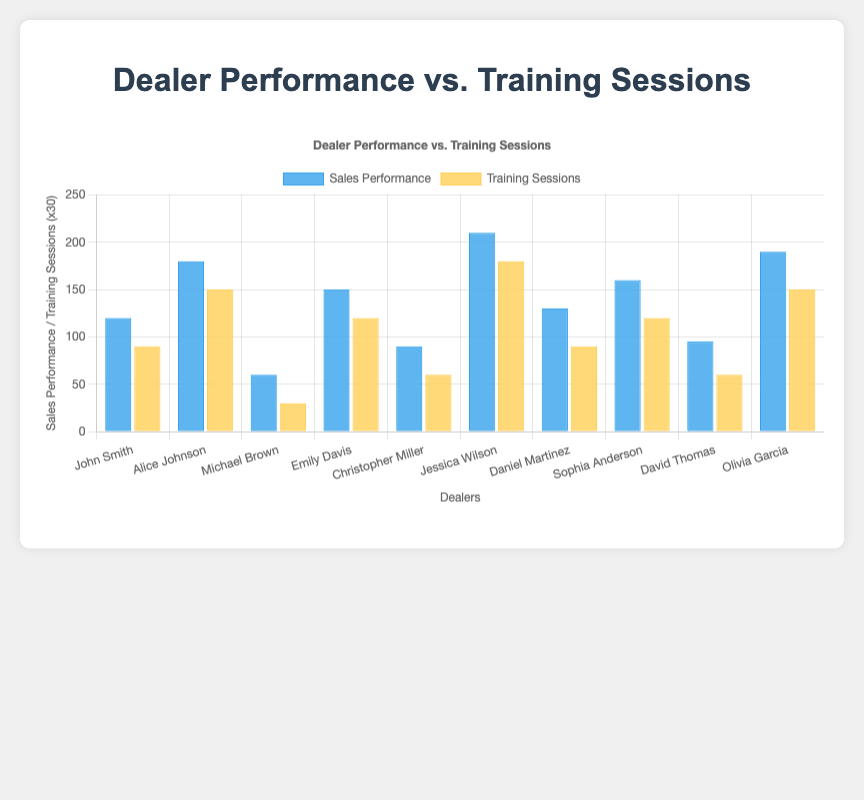Which dealer attended the most training sessions? By examining the height of the yellow bars representing training sessions, Jessica Wilson attended the most training sessions with a total of 6.
Answer: Jessica Wilson Which dealer had the highest sales performance? By observing the height of the blue bars, Jessica Wilson also had the highest sales performance with a value of 210.
Answer: Jessica Wilson What's the total number of training sessions attended by all dealers? Sum up the training sessions: 3 + 5 + 1 + 4 + 2 + 6 + 3 + 4 + 2 + 5 = 35
Answer: 35 Who has a better sales performance, John Smith or Emily Davis? John Smith has a sales performance of 120, while Emily Davis has a sales performance of 150. Therefore, Emily Davis has a better sales performance.
Answer: Emily Davis What is the average sales performance across all dealers? Sum up all sales performances and divide by the number of dealers: (120 + 180 + 60 + 150 + 90 + 210 + 130 + 160 + 95 + 190) / 10 = 1385 / 10 = 138.5
Answer: 138.5 Which dealers attended fewer than 3 training sessions and what is their total sales performance? Dealers with fewer than 3 training sessions are Michael Brown and Christopher Miller. Their total sales performance is 60 + 90 = 150.
Answer: 150 By how much does Olivia Garcia's sales performance exceed that of David Thomas? Olivia Garcia's sales performance is 190, and David Thomas's is 95. The difference is 190 - 95 = 95.
Answer: 95 How many more training sessions did Jessica Wilson attend compared to Christopher Miller? Jessica Wilson attended 6 training sessions, and Christopher Miller attended 2. The difference is 6 - 2 = 4.
Answer: 4 Which dealer has the closest sales performance to the average sales performance? The average sales performance is 138.5. Comparing the dealers' sales performances to 138.5, Daniel Martinez with 130 is the closest.
Answer: Daniel Martinez Which group of dealers, those who attended 4 or more sessions, or those who attended fewer than 4 sessions, had a higher average sales performance? - Dealers with 4 or more sessions: Alice Johnson (180), Emily Davis (150), Jessica Wilson (210), Sophia Anderson (160), Olivia Garcia (190). Total: 180 + 150 + 210 + 160 + 190 = 890, average = 890/5 = 178.
- Dealers with fewer than 4 sessions: John Smith (120), Michael Brown (60), Christopher Miller (90), Daniel Martinez (130), David Thomas (95). Total: 120 + 60 + 90 + 130 + 95 = 495, average = 495/5 = 99.
Group with 4 or more sessions had a higher average sales performance.
Answer: Group with 4 or more training sessions 